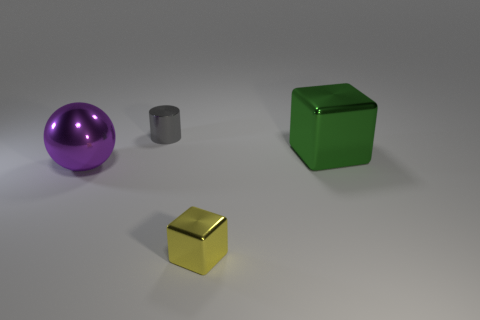Subtract all spheres. How many objects are left? 3 Subtract all green blocks. How many blocks are left? 1 Add 4 green metallic things. How many objects exist? 8 Add 4 balls. How many balls are left? 5 Add 1 tiny brown cubes. How many tiny brown cubes exist? 1 Subtract 1 gray cylinders. How many objects are left? 3 Subtract 1 cylinders. How many cylinders are left? 0 Subtract all brown spheres. Subtract all brown cylinders. How many spheres are left? 1 Subtract all big green metal objects. Subtract all small cylinders. How many objects are left? 2 